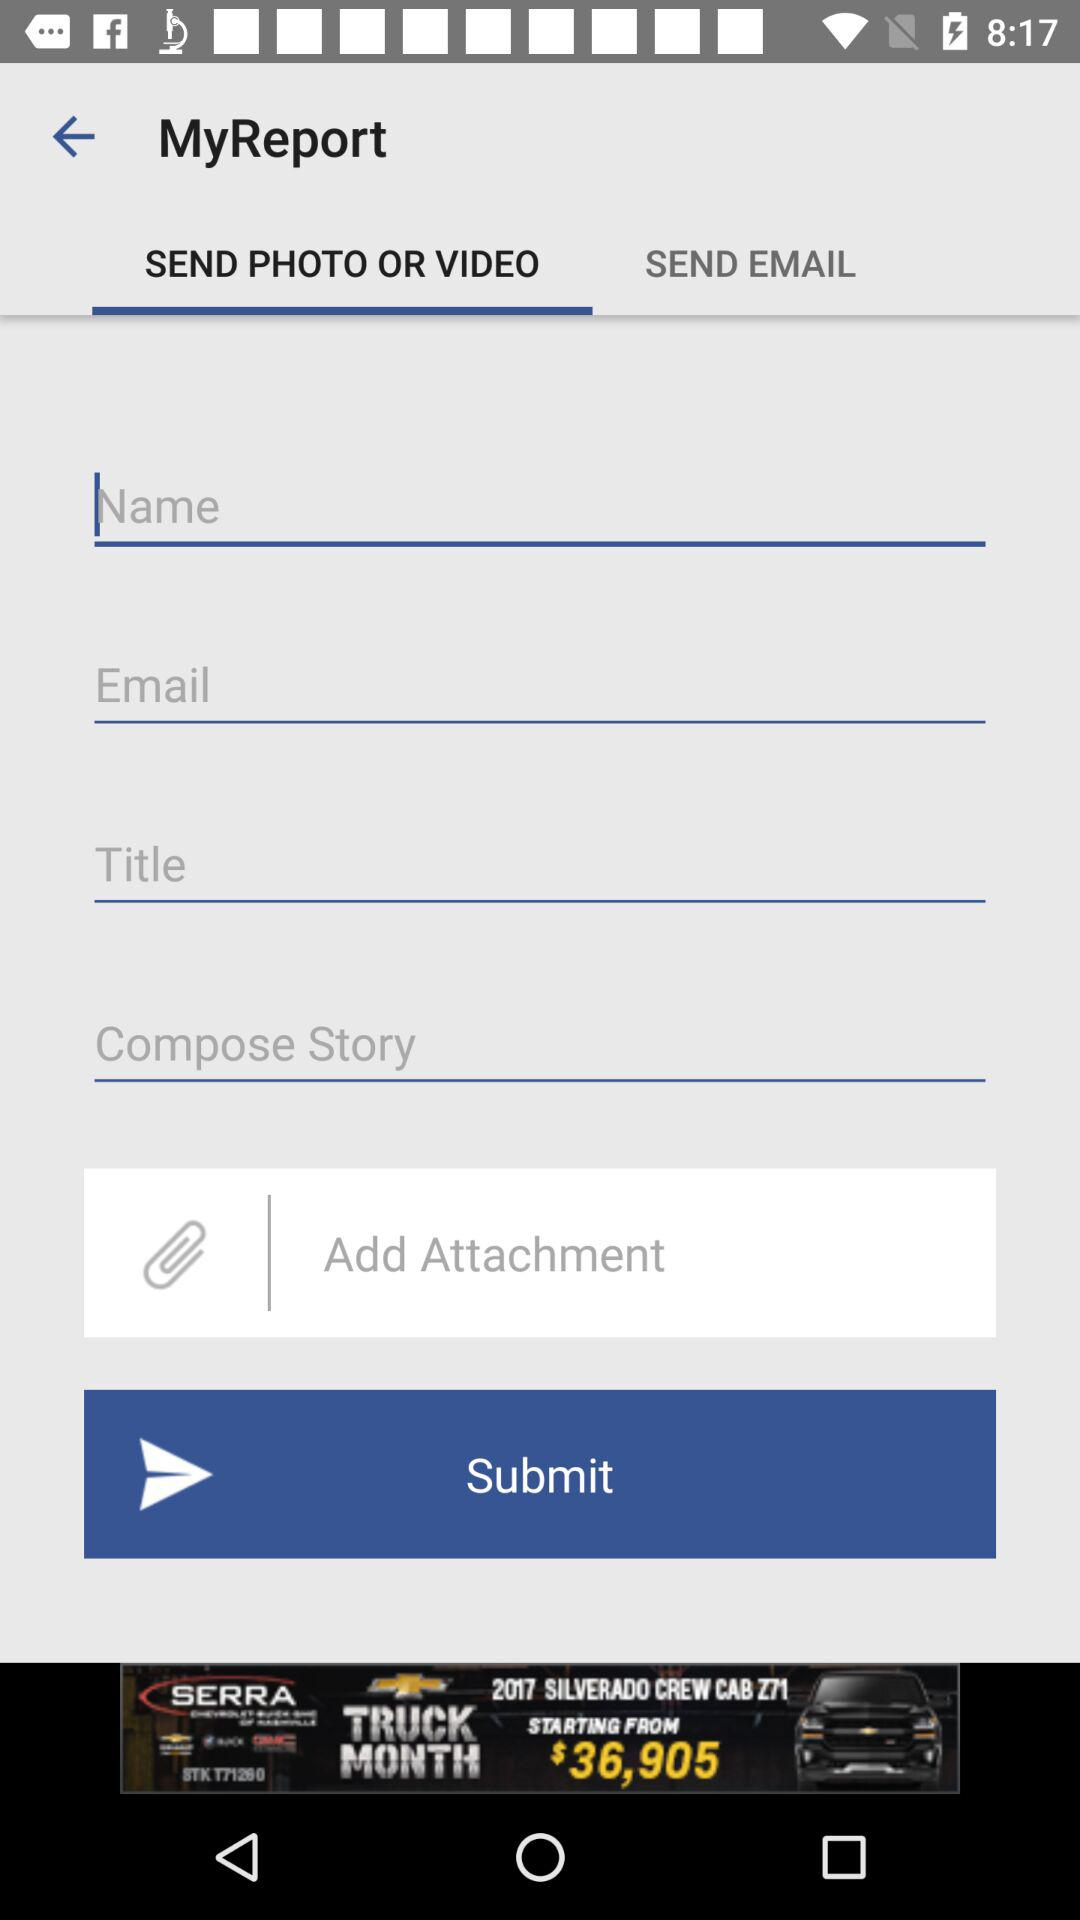Which tab is currently selected? The selected tab is "SEND PHOTO OR VIDEO". 